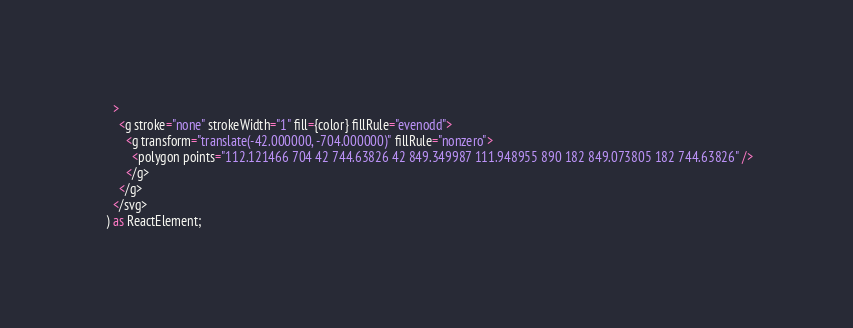<code> <loc_0><loc_0><loc_500><loc_500><_TypeScript_>    >
      <g stroke="none" strokeWidth="1" fill={color} fillRule="evenodd">
        <g transform="translate(-42.000000, -704.000000)" fillRule="nonzero">
          <polygon points="112.121466 704 42 744.63826 42 849.349987 111.948955 890 182 849.073805 182 744.63826" />
        </g>
      </g>
    </svg>
  ) as ReactElement;
</code> 